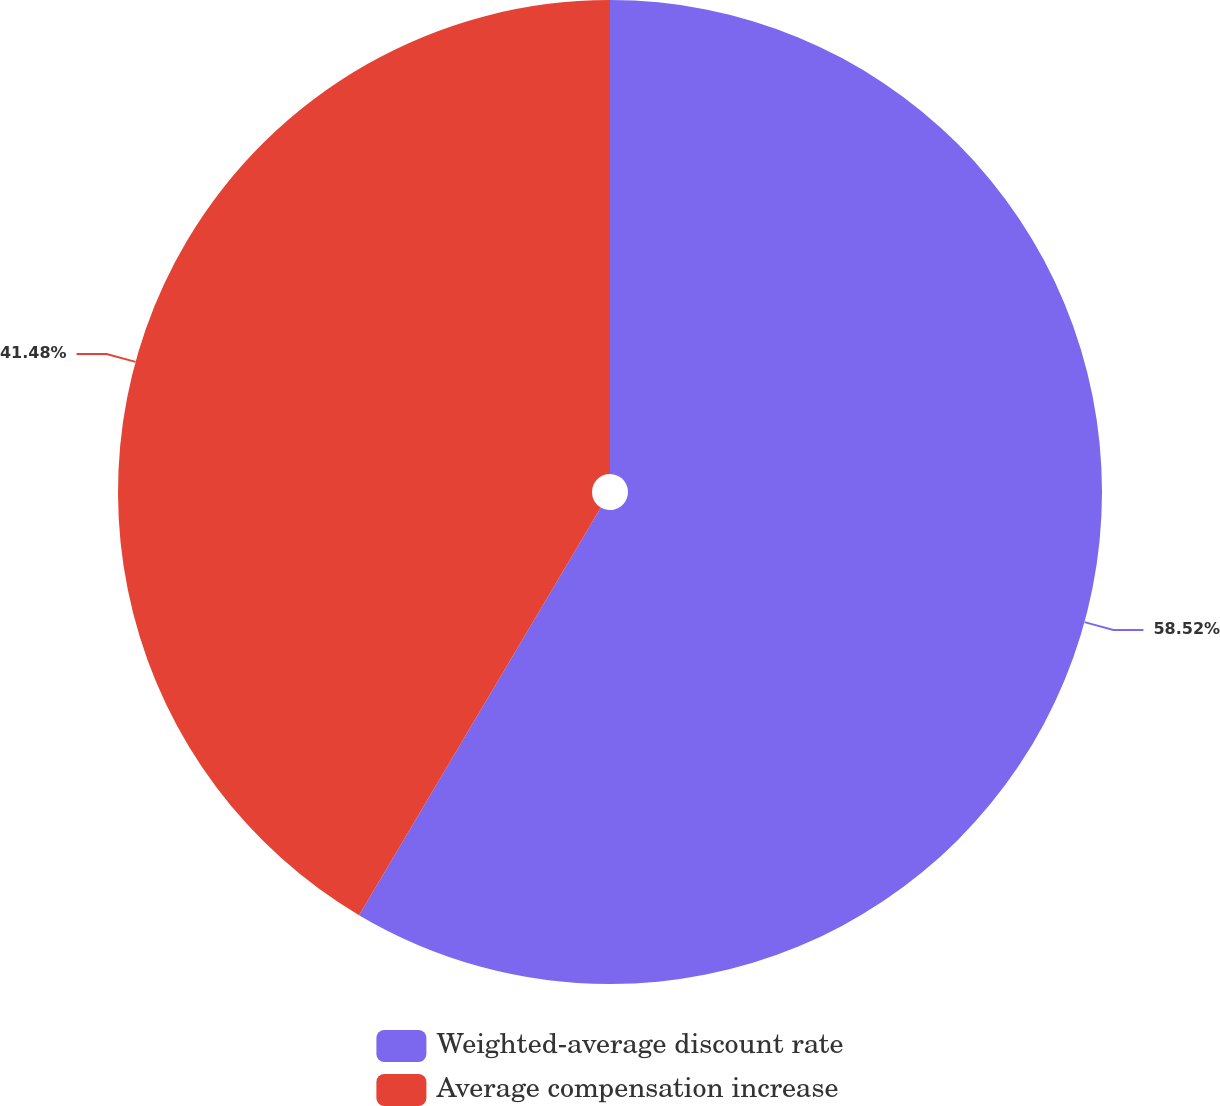Convert chart. <chart><loc_0><loc_0><loc_500><loc_500><pie_chart><fcel>Weighted-average discount rate<fcel>Average compensation increase<nl><fcel>58.52%<fcel>41.48%<nl></chart> 